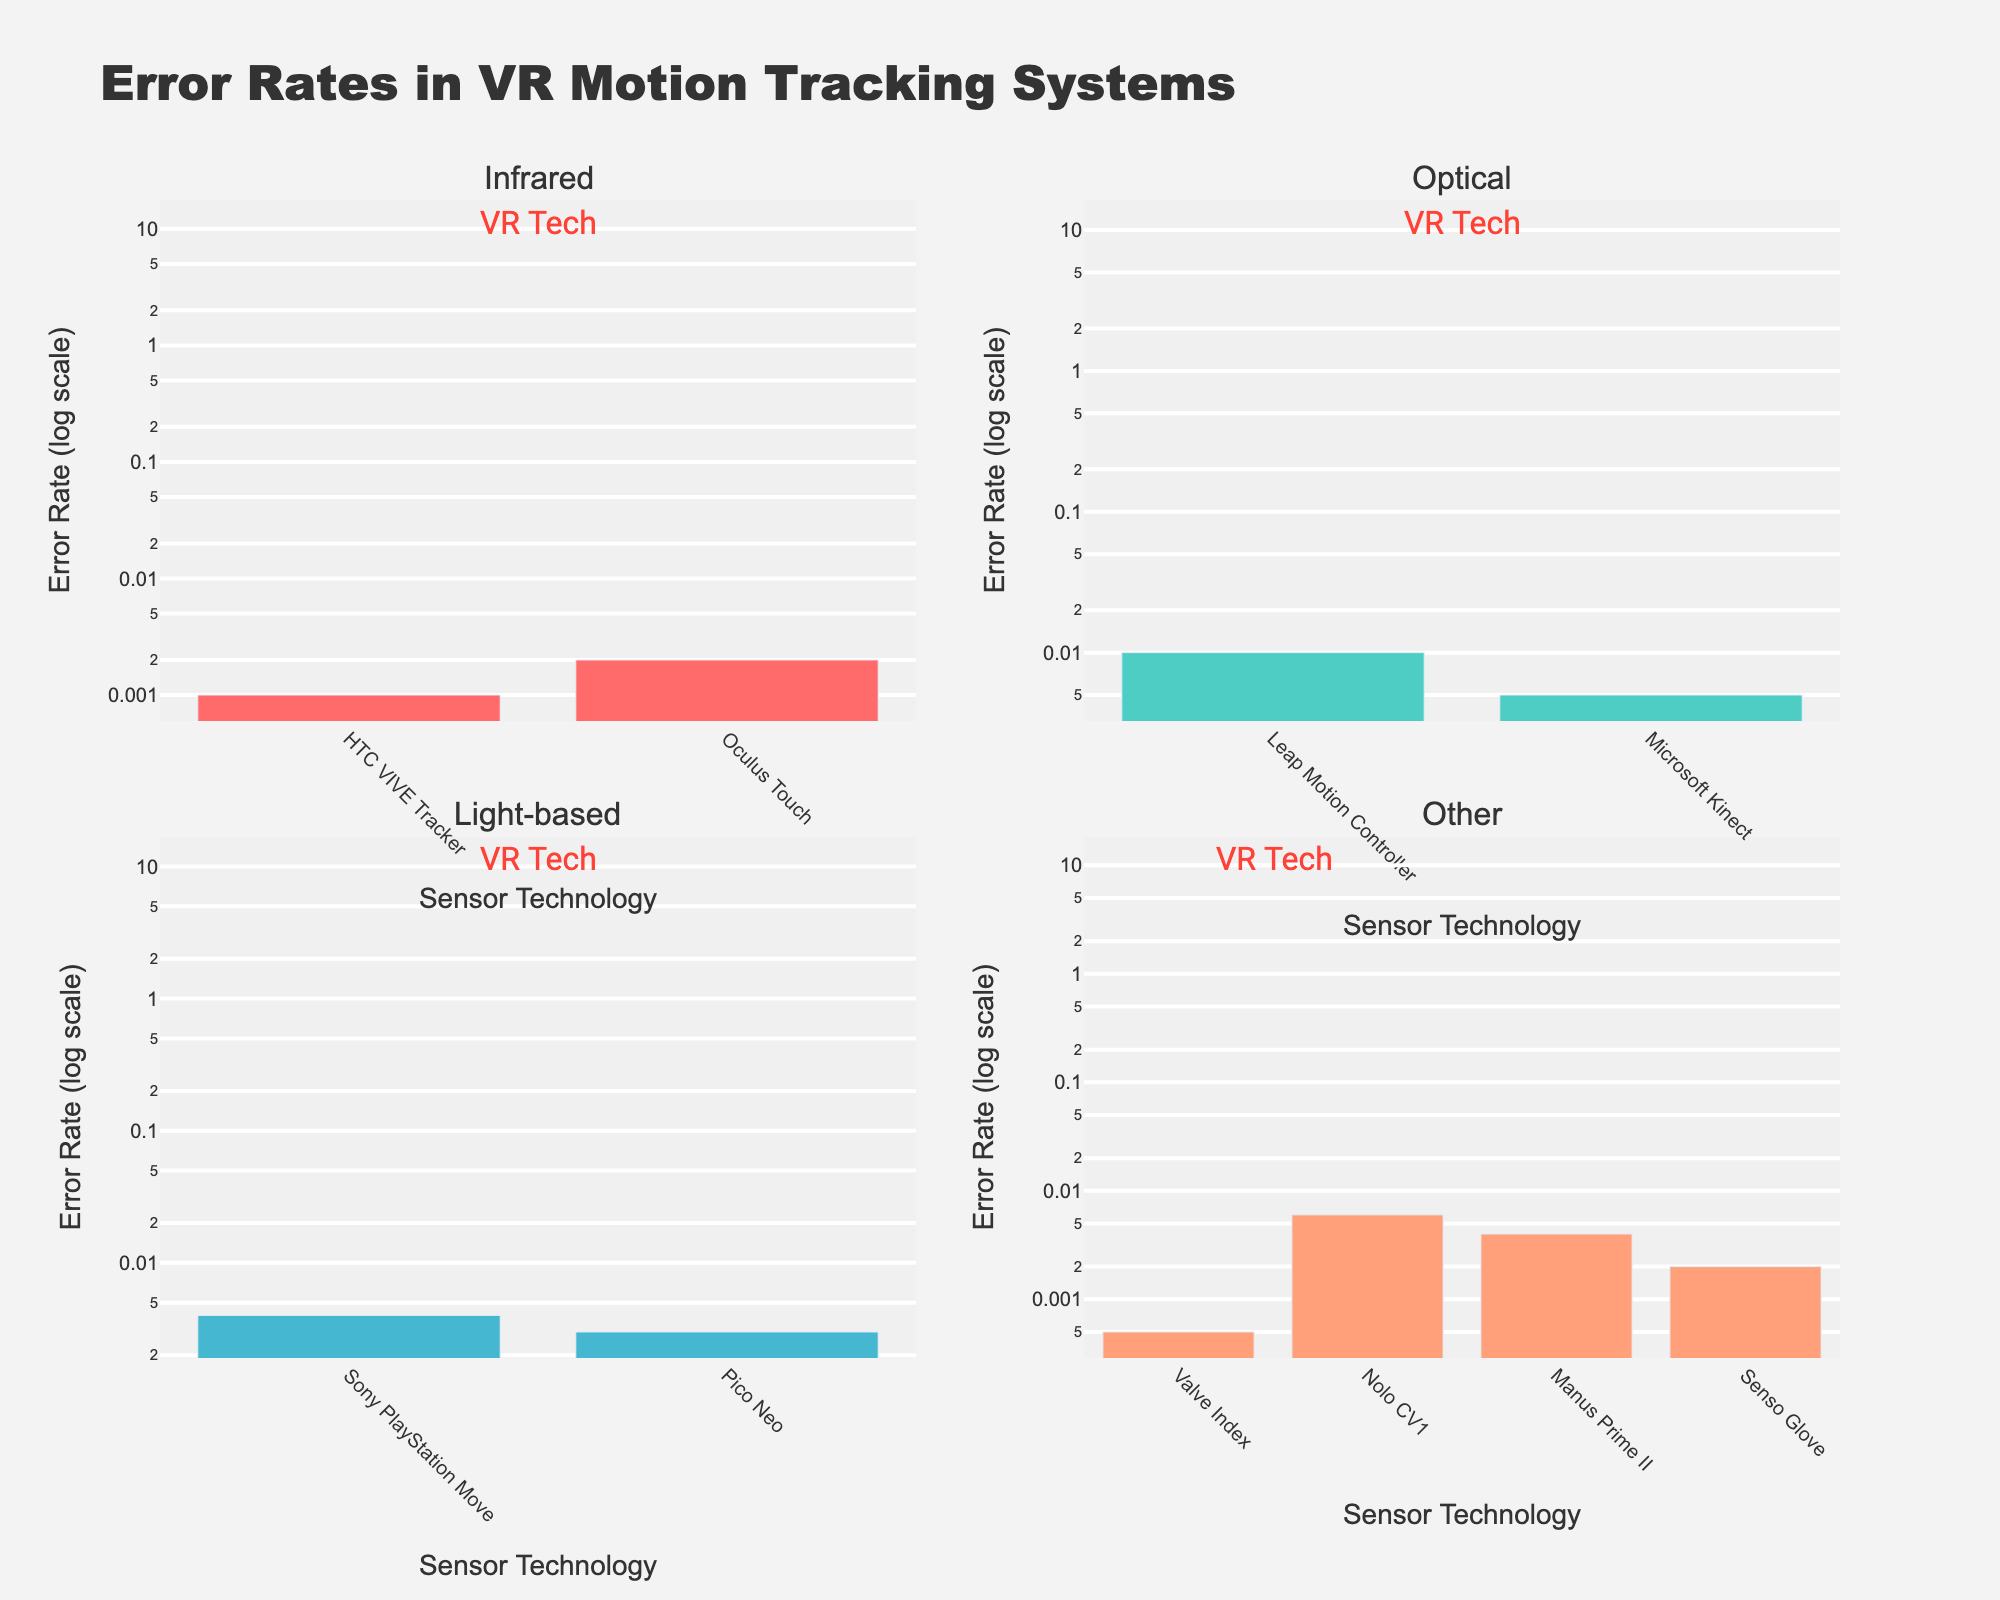What is the title of the figure? The title is located at the top of the figure, typically in a larger font size, making it easy to identify.
Answer: Error Rates in VR Motion Tracking Systems How many types of sensor technologies are shown in the figure? Each subplot has a title indicating different types of sensor technologies. By counting these titles, we can identify the number of types.
Answer: Four Which sensor technology has the lowest error rate in the Infrared category? Look at the bar heights in the subplot titled "Infrared"; the shortest bar represents the lowest error rate.
Answer: HTC VIVE Tracker Compare the error rates of Optical vs. Light-based sensors; which category generally has higher error rates? Analyze the bars within the "Optical" and "Light-based" subplots. Typically, bars with greater lengths represent higher error rates.
Answer: Optical What is the error rate range (difference between highest and lowest error rate) for Magnetic sensors? Identify the highest and lowest error rates within the subplot titled "Other." Subtract the smallest value from the largest value to find the range.
Answer: 0.002 Which category has the sensor with the lowest error rate overall? Look at all the subplots and identify the shortest bar across all categories.
Answer: Infrared By looking at the log scale on the y-axis, which sensor technology's error rate is exactly one order of magnitude higher than Valve Index? On a log scale, an order of magnitude difference is a tenfold increase. Find Valve Index in the figure and locate the bar that is one order higher above it.
Answer: Oculus Touch Between Infrared and Light-based sensors, which category shows a more consistent error rate (less variation among sensors)? Compare the variation in the bar heights within the "Infrared" and "Light-based" subplots. Consistency means the bars are closer in height.
Answer: Light-based Which sensor technology has the highest error rate in the Optical category? Locate the "Optical" subplot and identify the bar with the greatest height, representing the highest error rate.
Answer: Leap Motion Controller What is the difference in error rates between the highest and lowest error rate sensors in the "Other" category? Find the bars with the highest and lowest error rates in the "Other" subplot and subtract the lowest value from the highest.
Answer: 0.004 